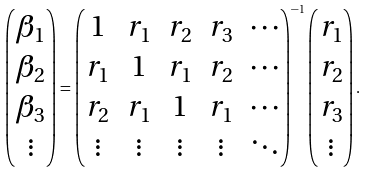Convert formula to latex. <formula><loc_0><loc_0><loc_500><loc_500>\begin{pmatrix} \beta _ { 1 } \\ \beta _ { 2 } \\ \beta _ { 3 } \\ \vdots \end{pmatrix} = \begin{pmatrix} 1 & r _ { 1 } & r _ { 2 } & r _ { 3 } & \cdots \\ r _ { 1 } & 1 & r _ { 1 } & r _ { 2 } & \cdots \\ r _ { 2 } & r _ { 1 } & 1 & r _ { 1 } & \cdots \\ \vdots & \vdots & \vdots & \vdots & \ddots \\ \end{pmatrix} ^ { - 1 } \begin{pmatrix} r _ { 1 } \\ r _ { 2 } \\ r _ { 3 } \\ \vdots \end{pmatrix} .</formula> 